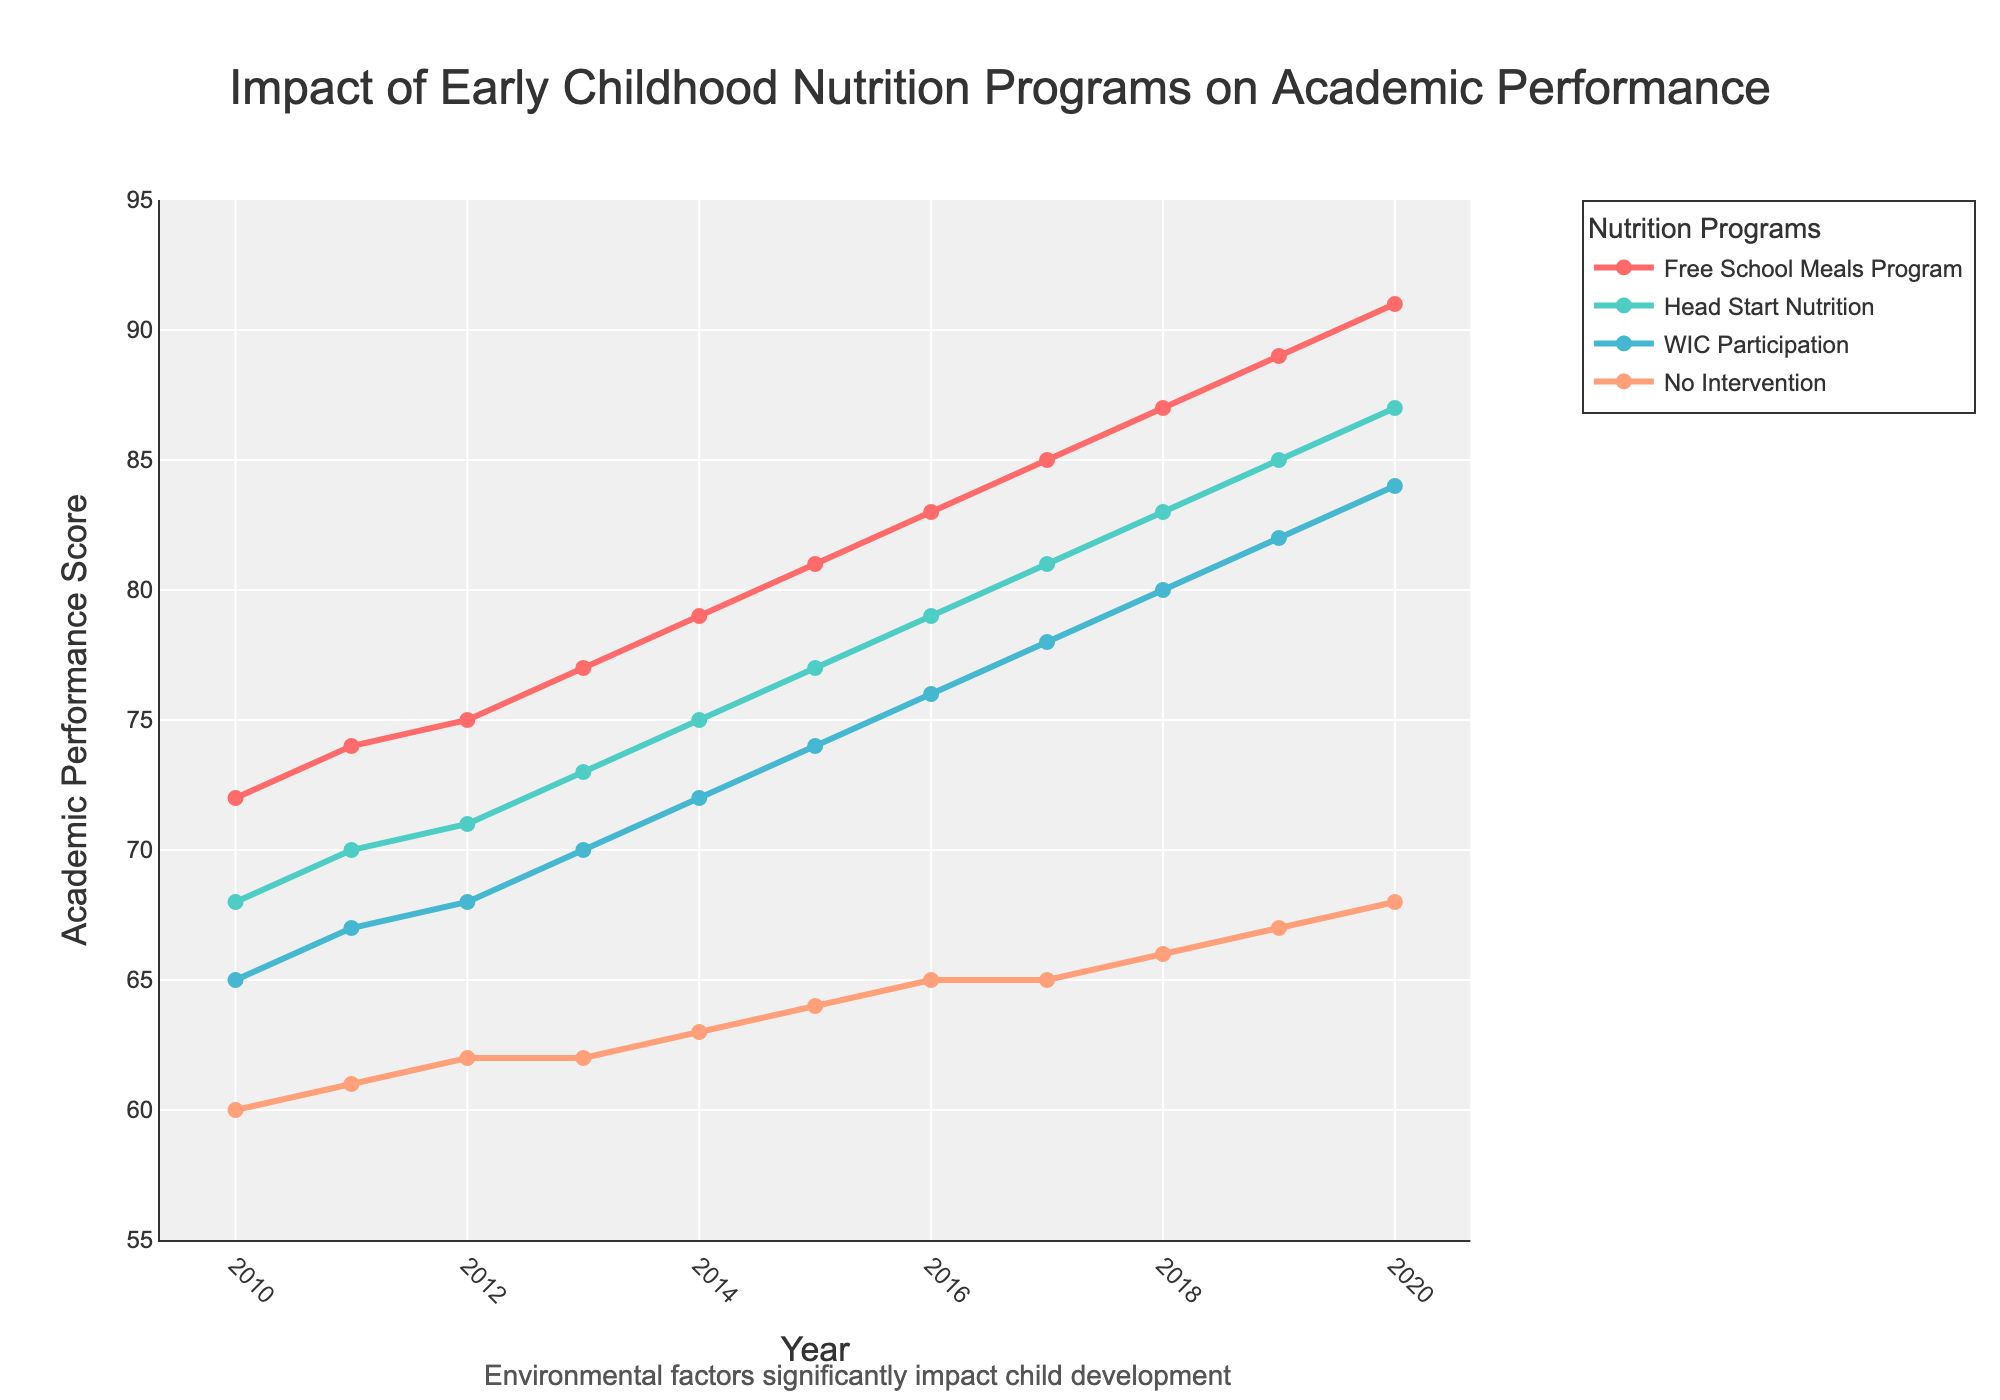What is the trend in academic performance for students involved in the Free School Meals Program from 2010 to 2020? The line representing the Free School Meals Program shows a steady increase from 72 in 2010 to 91 in 2020.
Answer: It shows a steady increase Between 2015 and 2020, which nutrition program saw the greatest improvement in academic performance? By observing the slopes of the lines between 2015 and 2020, the Free School Meals Program increased from 81 to 91, an increase of 10 points, the highest among all programs.
Answer: Free School Meals Program What is the difference in academic performance scores in 2020 between students with no intervention and those in the Head Start Nutrition program? In 2020, the score for No Intervention is 68 and for Head Start Nutrition is 87. The difference is 87 - 68 = 19.
Answer: 19 Which nutrition program had the lowest academic performance score in 2017, and what was that score? By observing the lines and their respective labels, the No Intervention program had the lowest score in 2017 with a score of 65.
Answer: No Intervention, 65 By how much did the academic performance score for WIC Participation increase from 2013 to 2018? In 2013, the WIC Participation score was 70, and in 2018, it was 80. The increase is 80 - 70 = 10.
Answer: 10 How does the academic performance score for the Free School Meals Program compare to No Intervention in 2014? In 2014, the score for the Free School Meals Program is 79, and for No Intervention, it is 63. Therefore, the Free School Meals Program score is 79 - 63 = 16 points higher.
Answer: 16 points higher Which program had the highest academic performance score in 2019? Observing the highest point on the graph for the year 2019, the Free School Meals Program had the highest score with 89.
Answer: Free School Meals Program What is the overall pattern observed for students with no intervention from 2010 to 2020? The line for No Intervention shows a slow and steady increase from 60 in 2010 to 68 in 2020.
Answer: Slow and steady increase What was the average academic performance score for students in the WIC Participation program between 2010 and 2020? Summing up the WIC Participation scores from 2010 to 2020 gives (65 + 67 + 68 + 70 + 72 + 74 + 76 + 78 + 80 + 82 + 84) = 816. Dividing by the number of years (11) gives 816 / 11 ≈ 74.18.
Answer: Approximately 74.18 Which program shows the most significant improvement trend over the decade? By comparing the overall increase in scores for each program, the Free School Meals Program rose from 72 in 2010 to 91 in 2020, an increase of 19 points, which is the largest among all programs.
Answer: Free School Meals Program 